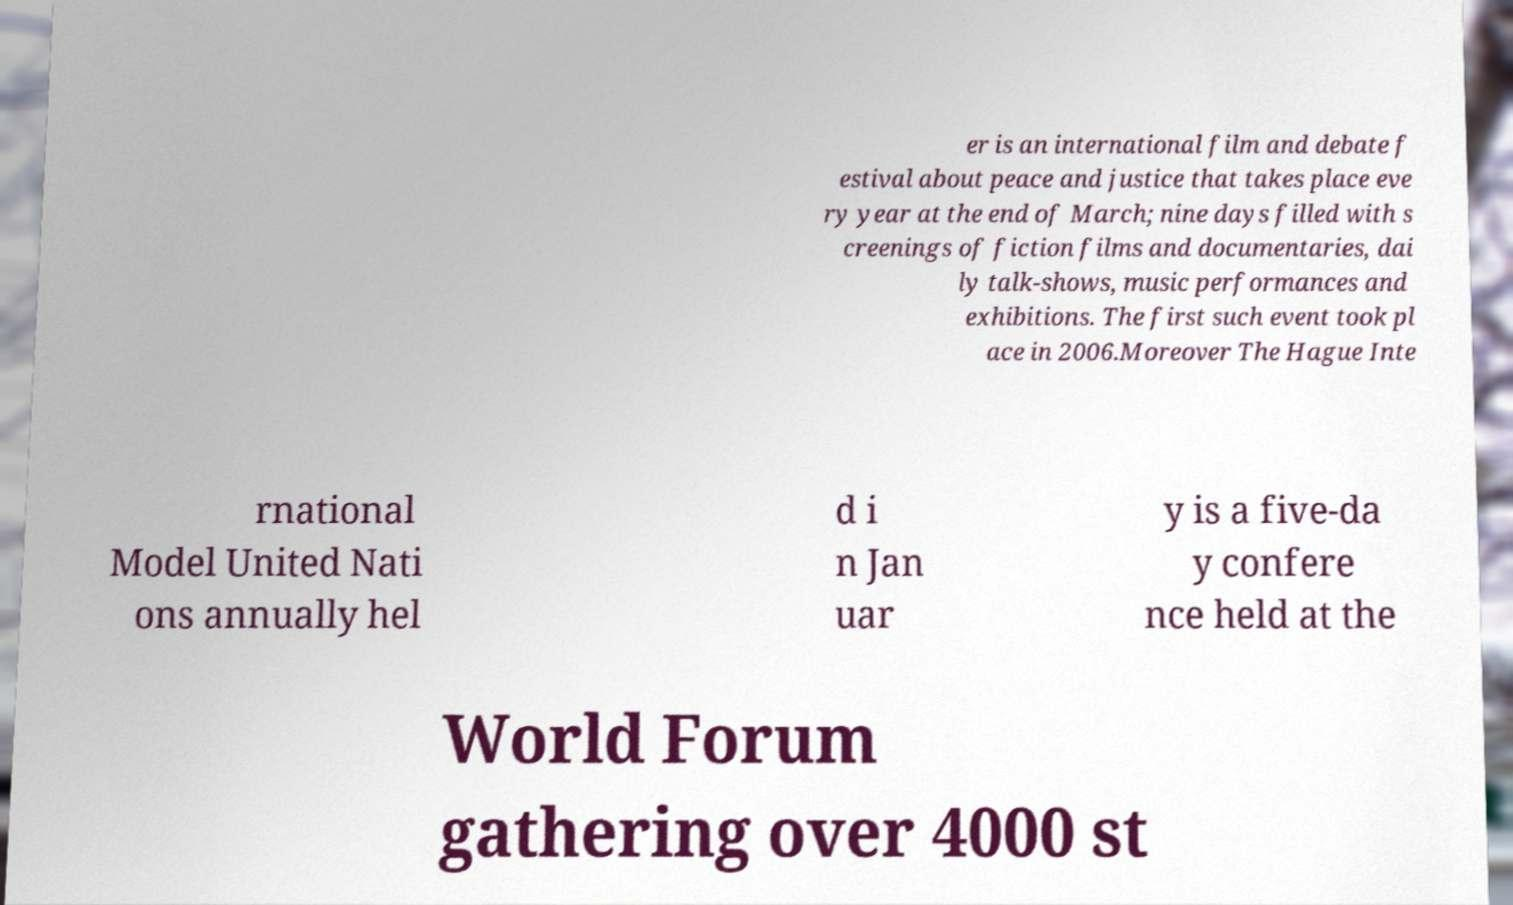I need the written content from this picture converted into text. Can you do that? er is an international film and debate f estival about peace and justice that takes place eve ry year at the end of March; nine days filled with s creenings of fiction films and documentaries, dai ly talk-shows, music performances and exhibitions. The first such event took pl ace in 2006.Moreover The Hague Inte rnational Model United Nati ons annually hel d i n Jan uar y is a five-da y confere nce held at the World Forum gathering over 4000 st 